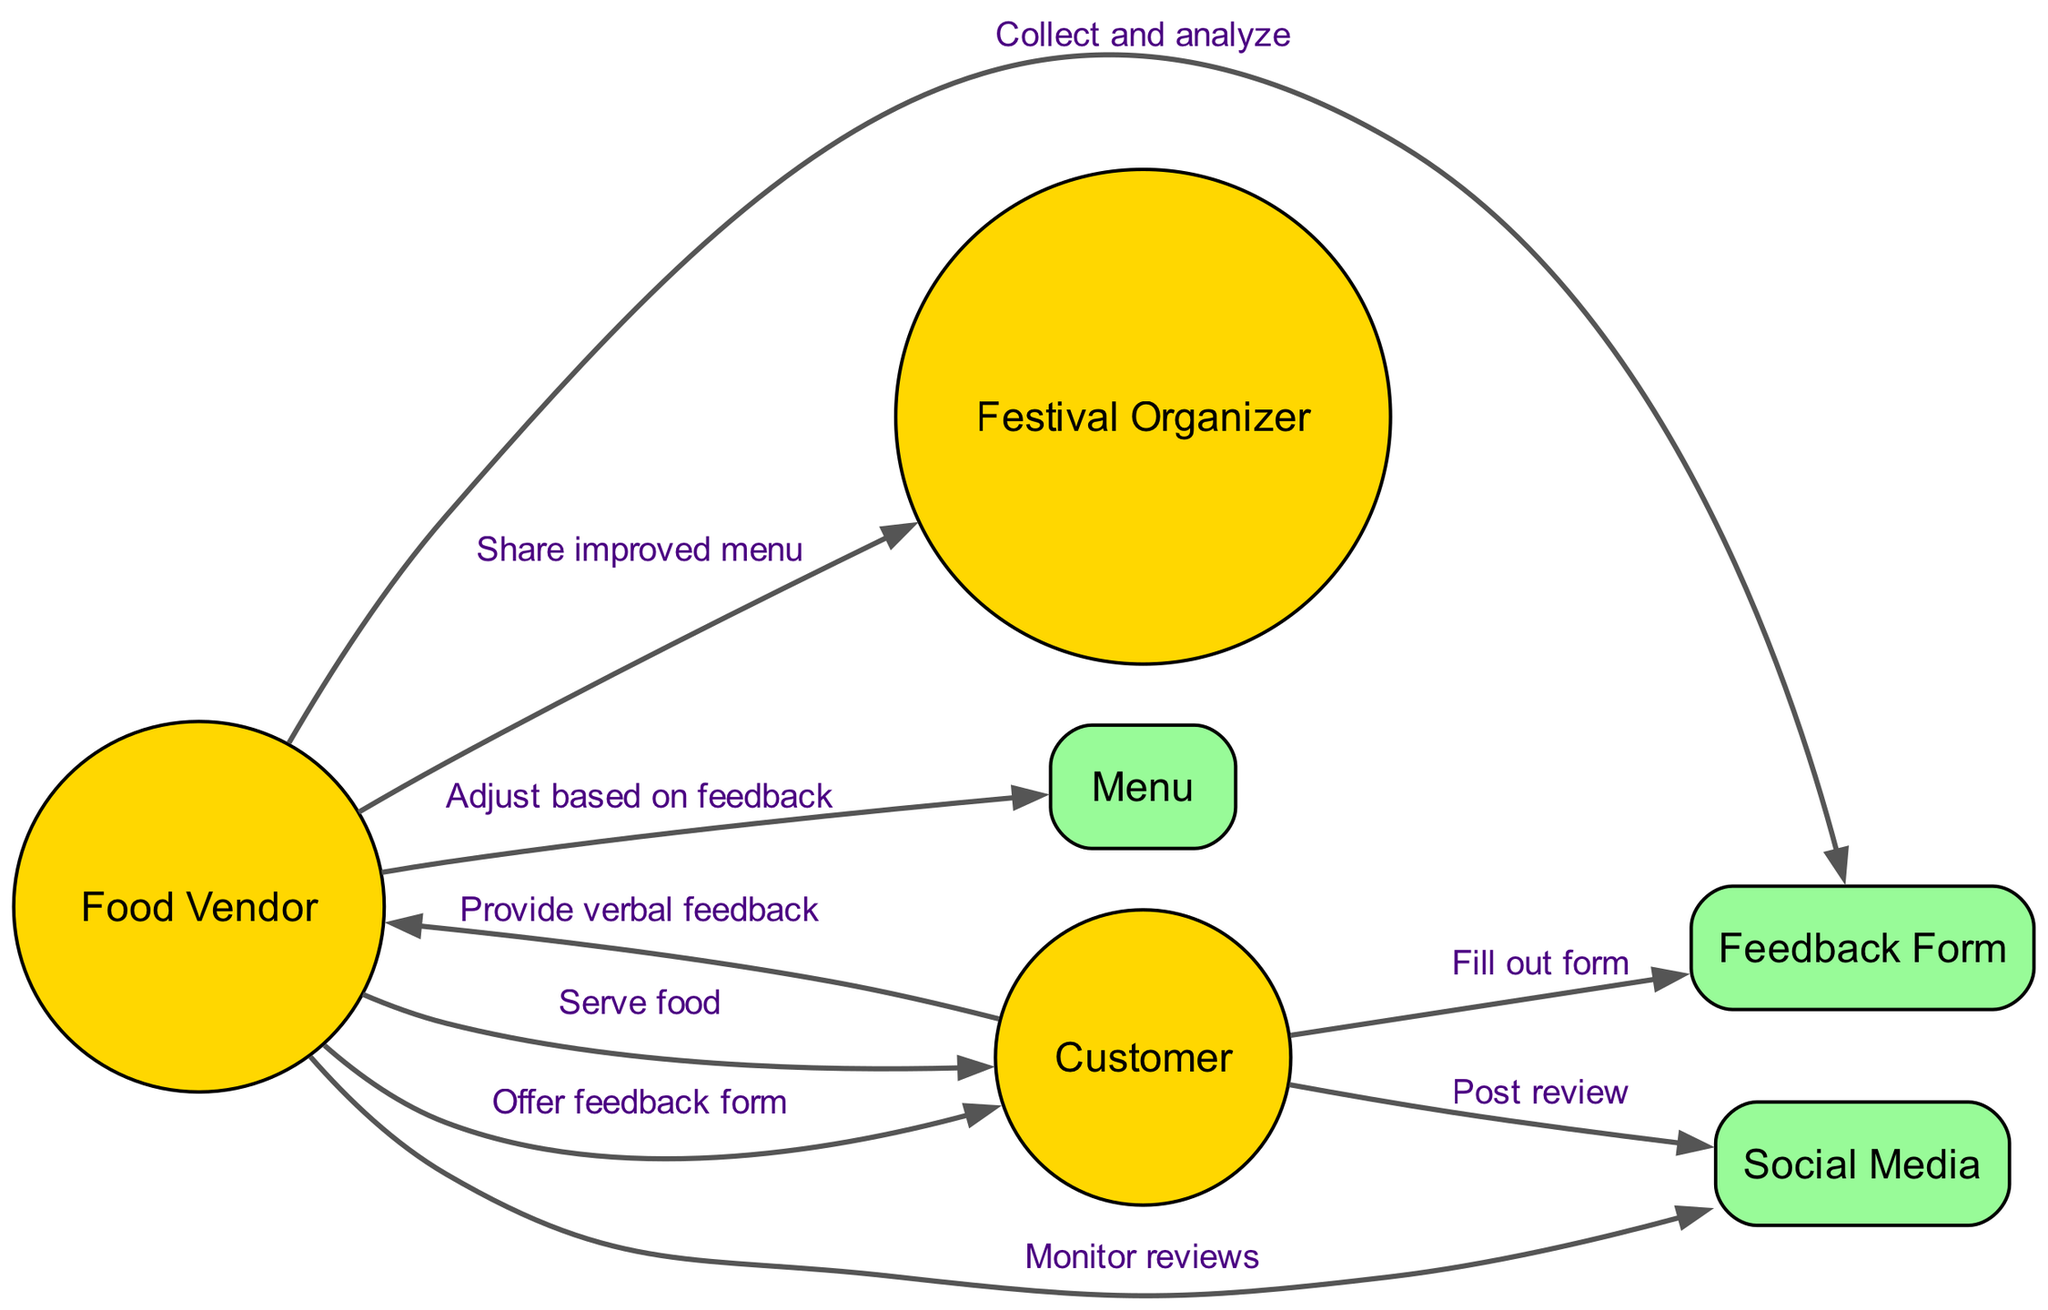What are the actors involved in the feedback process? The diagram lists three actors involved: the Food Vendor, the Customer, and the Festival Organizer. By identifying the nodes categorized as actors, we can determine who participates in this feedback loop.
Answer: Food Vendor, Customer, Festival Organizer How many objects are shown in the diagram? The diagram includes three objects: Menu, Feedback Form, and Social Media. Counting the nodes categorized as objects gives us the total number of objects in the sequence.
Answer: 3 What action does the Customer take after receiving food? The diagram indicates that after receiving food from the Food Vendor, the Customer provides verbal feedback. This is a direct action shown flowing from the Customer to the Food Vendor.
Answer: Provide verbal feedback How does the Food Vendor collect feedback? The Food Vendor collects feedback by offering a feedback form to the Customer and subsequently analyzing responses. The diagram shows the Food Vendor first offering the form, after which the Customer fills it out, leading to feedback analysis.
Answer: Offer feedback form Which social media action is indicated for the Customer? The diagram shows the Customer posting a review on social media after interacting with the Food Vendor. This indicates feedback provided through a digital platform.
Answer: Post review What does the Food Vendor do after collecting feedback? After collecting feedback, the Food Vendor adjusts the Menu based on the feedback received. This reflects the vendor’s process of using feedback for menu improvement, showing a direct relationship between analyzing feedback and making menu adjustments.
Answer: Adjust based on feedback What is the Food Vendor's final action in the feedback loop? The final action taken by the Food Vendor in this feedback loop is to share the improved menu with the Festival Organizer. This step represents the conclusion of the feedback process, linking it back to the broader festival context.
Answer: Share improved menu How does the Food Vendor monitor additional feedback? The Food Vendor monitors additional feedback through Social Media, which indicates an ongoing engagement with customer opinions beyond just collecting feedback forms. This step shows the Vendor’s proactive approach in observing customer reviews online.
Answer: Monitor reviews 